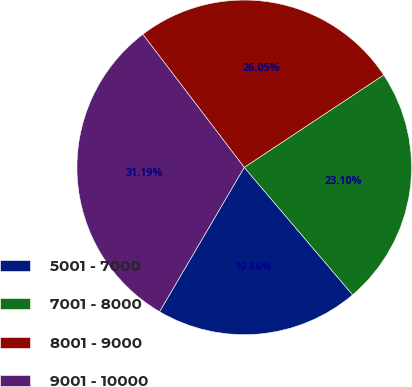<chart> <loc_0><loc_0><loc_500><loc_500><pie_chart><fcel>5001 - 7000<fcel>7001 - 8000<fcel>8001 - 9000<fcel>9001 - 10000<nl><fcel>19.66%<fcel>23.1%<fcel>26.05%<fcel>31.19%<nl></chart> 